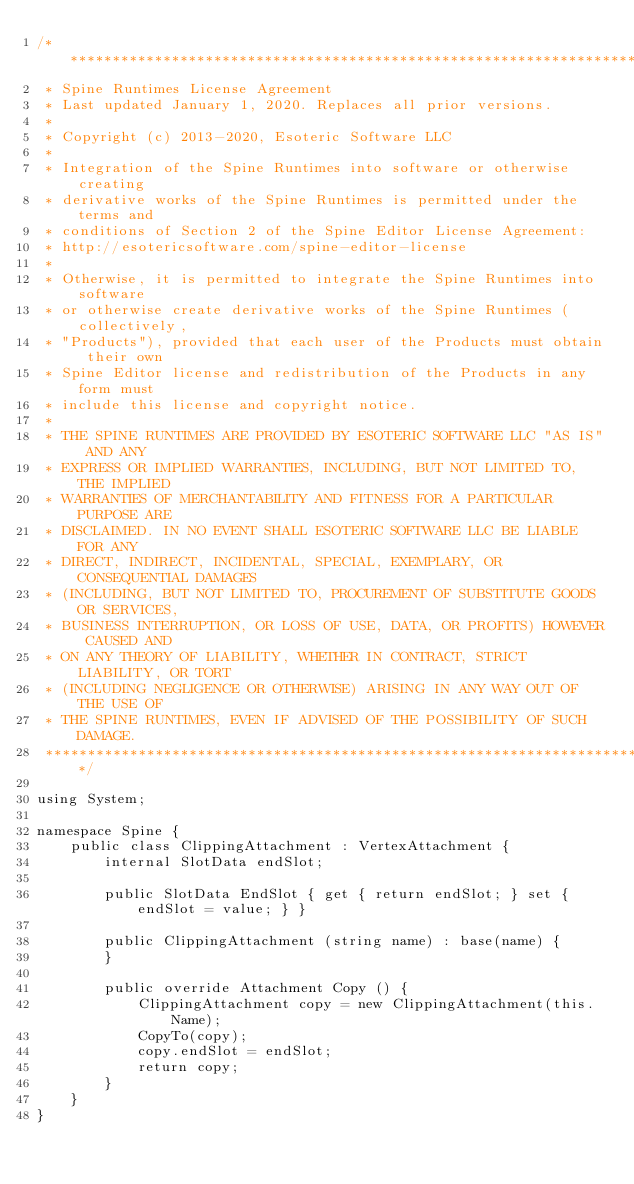Convert code to text. <code><loc_0><loc_0><loc_500><loc_500><_C#_>/******************************************************************************
 * Spine Runtimes License Agreement
 * Last updated January 1, 2020. Replaces all prior versions.
 *
 * Copyright (c) 2013-2020, Esoteric Software LLC
 *
 * Integration of the Spine Runtimes into software or otherwise creating
 * derivative works of the Spine Runtimes is permitted under the terms and
 * conditions of Section 2 of the Spine Editor License Agreement:
 * http://esotericsoftware.com/spine-editor-license
 *
 * Otherwise, it is permitted to integrate the Spine Runtimes into software
 * or otherwise create derivative works of the Spine Runtimes (collectively,
 * "Products"), provided that each user of the Products must obtain their own
 * Spine Editor license and redistribution of the Products in any form must
 * include this license and copyright notice.
 *
 * THE SPINE RUNTIMES ARE PROVIDED BY ESOTERIC SOFTWARE LLC "AS IS" AND ANY
 * EXPRESS OR IMPLIED WARRANTIES, INCLUDING, BUT NOT LIMITED TO, THE IMPLIED
 * WARRANTIES OF MERCHANTABILITY AND FITNESS FOR A PARTICULAR PURPOSE ARE
 * DISCLAIMED. IN NO EVENT SHALL ESOTERIC SOFTWARE LLC BE LIABLE FOR ANY
 * DIRECT, INDIRECT, INCIDENTAL, SPECIAL, EXEMPLARY, OR CONSEQUENTIAL DAMAGES
 * (INCLUDING, BUT NOT LIMITED TO, PROCUREMENT OF SUBSTITUTE GOODS OR SERVICES,
 * BUSINESS INTERRUPTION, OR LOSS OF USE, DATA, OR PROFITS) HOWEVER CAUSED AND
 * ON ANY THEORY OF LIABILITY, WHETHER IN CONTRACT, STRICT LIABILITY, OR TORT
 * (INCLUDING NEGLIGENCE OR OTHERWISE) ARISING IN ANY WAY OUT OF THE USE OF
 * THE SPINE RUNTIMES, EVEN IF ADVISED OF THE POSSIBILITY OF SUCH DAMAGE.
 *****************************************************************************/

using System;

namespace Spine {
	public class ClippingAttachment : VertexAttachment {
		internal SlotData endSlot;

		public SlotData EndSlot { get { return endSlot; } set { endSlot = value; } }

		public ClippingAttachment (string name) : base(name) {
		}

		public override Attachment Copy () {
			ClippingAttachment copy = new ClippingAttachment(this.Name);
			CopyTo(copy);
			copy.endSlot = endSlot;
			return copy;
		}
	}
}
</code> 